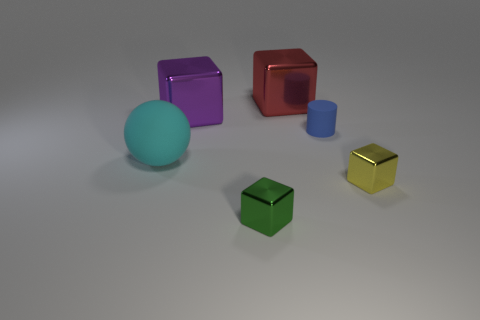Subtract all red cubes. How many cubes are left? 3 Subtract all small green metallic blocks. How many blocks are left? 3 Add 3 yellow cylinders. How many objects exist? 9 Subtract all cubes. How many objects are left? 2 Subtract all yellow cubes. Subtract all yellow cylinders. How many cubes are left? 3 Add 5 tiny green objects. How many tiny green objects exist? 6 Subtract 0 brown cubes. How many objects are left? 6 Subtract all red shiny blocks. Subtract all blue objects. How many objects are left? 4 Add 3 tiny cylinders. How many tiny cylinders are left? 4 